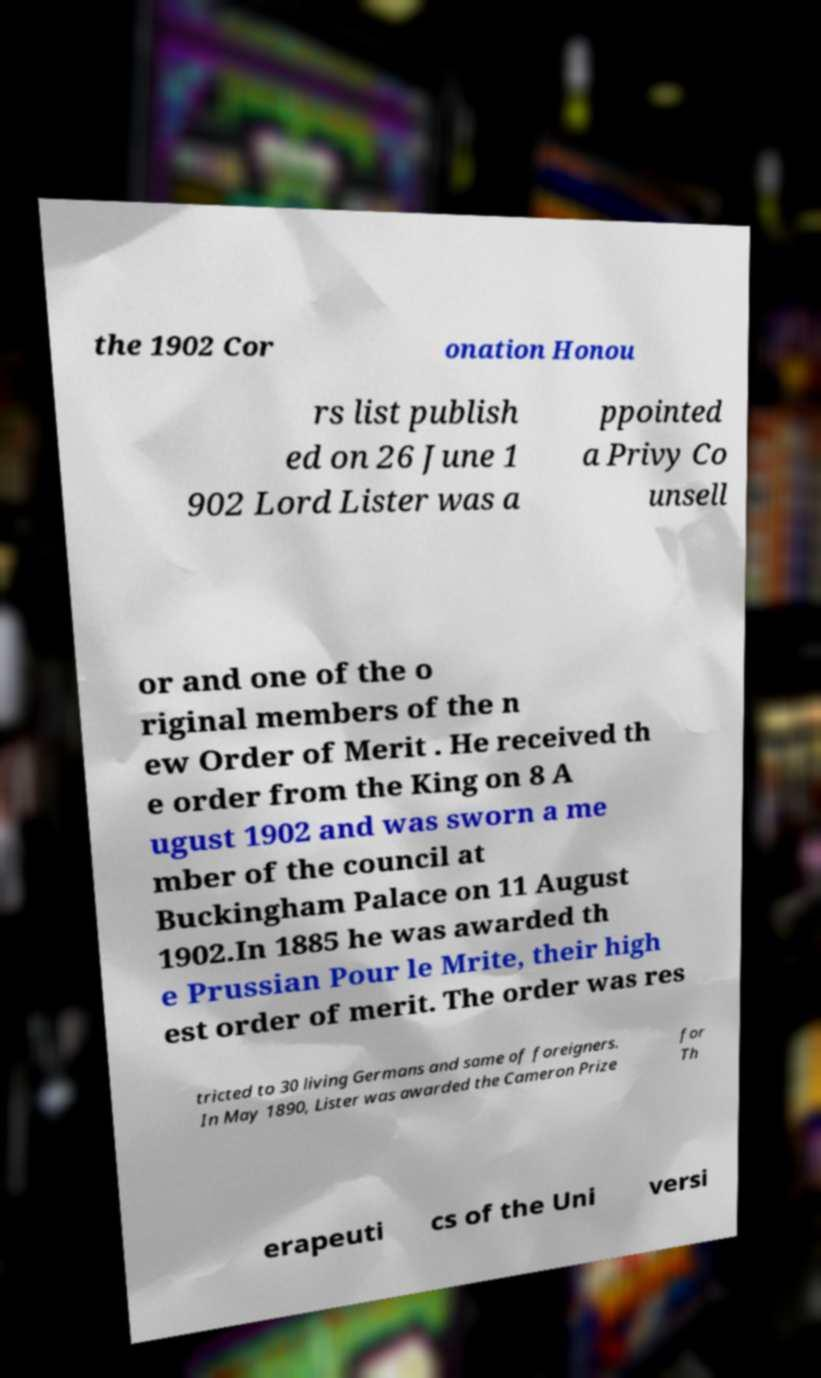Can you read and provide the text displayed in the image?This photo seems to have some interesting text. Can you extract and type it out for me? the 1902 Cor onation Honou rs list publish ed on 26 June 1 902 Lord Lister was a ppointed a Privy Co unsell or and one of the o riginal members of the n ew Order of Merit . He received th e order from the King on 8 A ugust 1902 and was sworn a me mber of the council at Buckingham Palace on 11 August 1902.In 1885 he was awarded th e Prussian Pour le Mrite, their high est order of merit. The order was res tricted to 30 living Germans and same of foreigners. In May 1890, Lister was awarded the Cameron Prize for Th erapeuti cs of the Uni versi 